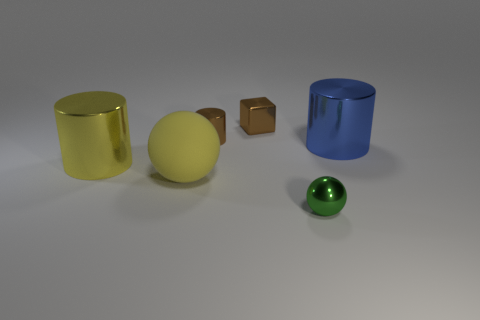What size is the other object that is the same shape as the rubber object?
Give a very brief answer. Small. Is the color of the rubber ball the same as the cylinder left of the large yellow matte ball?
Your answer should be very brief. Yes. Do the object behind the brown cylinder and the small metallic object to the left of the brown metal cube have the same color?
Provide a short and direct response. Yes. There is a blue thing that is the same shape as the large yellow metallic thing; what is it made of?
Keep it short and to the point. Metal. The blue cylinder that is the same material as the green ball is what size?
Your response must be concise. Large. How many blue objects are either metallic cylinders or shiny things?
Offer a very short reply. 1. There is a large cylinder on the left side of the cube; how many big yellow metal cylinders are in front of it?
Give a very brief answer. 0. Is the number of things that are behind the large yellow cylinder greater than the number of brown objects in front of the blue object?
Keep it short and to the point. Yes. What material is the small brown block?
Your response must be concise. Metal. Is there a green rubber sphere of the same size as the yellow metallic thing?
Provide a succinct answer. No. 